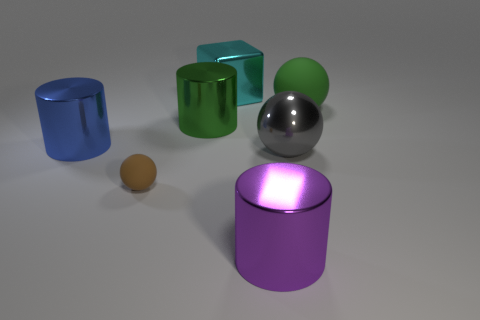What color is the cube that is the same material as the large purple cylinder? cyan 